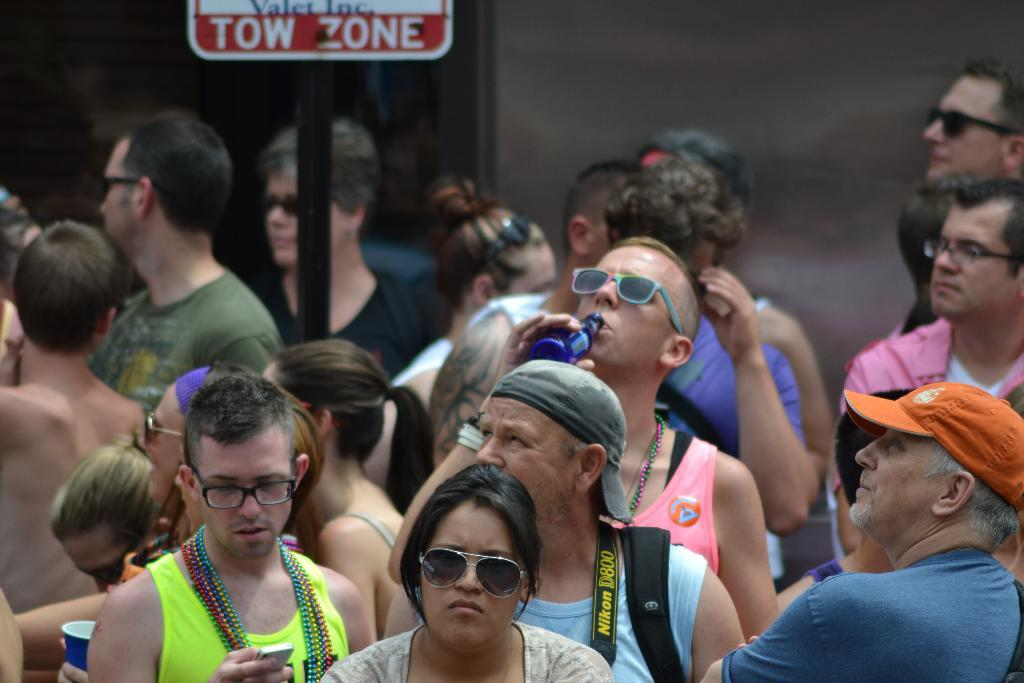What are the people in the image doing? The people in the image are standing on the ground. What are the people looking at or towards? The people are looking in a particular direction. What can be seen in the background of the image? There is a sign board visible in the background of the image. What type of fireman is visible in the image? There is no fireman present in the image. What room are the people standing in? The image does not provide information about the room or any enclosed space the people are standing in. 